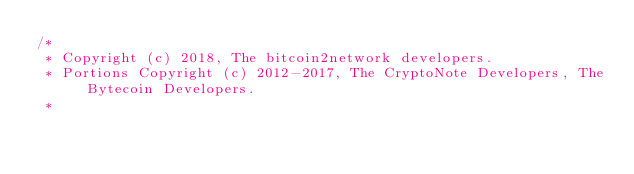Convert code to text. <code><loc_0><loc_0><loc_500><loc_500><_C_>/*
 * Copyright (c) 2018, The bitcoin2network developers.
 * Portions Copyright (c) 2012-2017, The CryptoNote Developers, The Bytecoin Developers.
 *</code> 